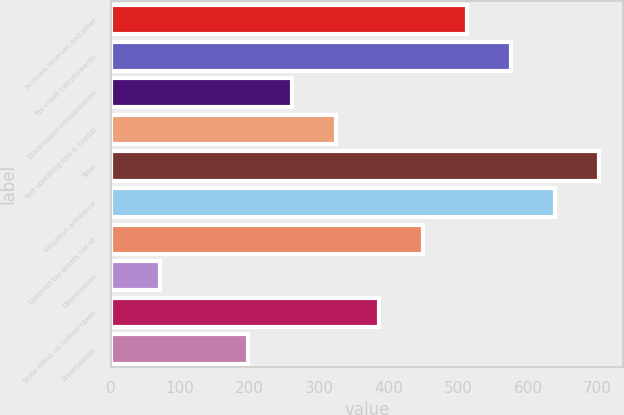Convert chart to OTSL. <chart><loc_0><loc_0><loc_500><loc_500><bar_chart><fcel>Accruals reserves and other<fcel>Tax credit carryforwards<fcel>Stock-based compensation<fcel>Net operating loss & capital<fcel>Total<fcel>Valuation allowance<fcel>Deferred tax assets net of<fcel>Depreciation<fcel>State effect on federal taxes<fcel>Amortization<nl><fcel>512.8<fcel>575.9<fcel>260.4<fcel>323.5<fcel>702.1<fcel>639<fcel>449.7<fcel>71.1<fcel>386.6<fcel>197.3<nl></chart> 